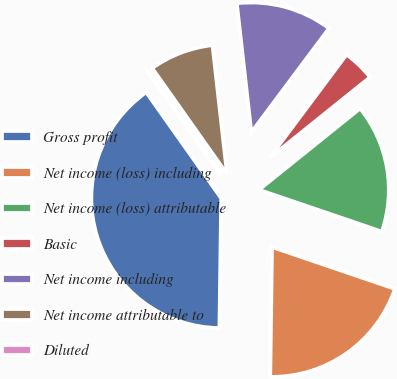Convert chart. <chart><loc_0><loc_0><loc_500><loc_500><pie_chart><fcel>Gross profit<fcel>Net income (loss) including<fcel>Net income (loss) attributable<fcel>Basic<fcel>Net income including<fcel>Net income attributable to<fcel>Diluted<nl><fcel>39.99%<fcel>20.0%<fcel>16.0%<fcel>4.01%<fcel>12.0%<fcel>8.0%<fcel>0.01%<nl></chart> 